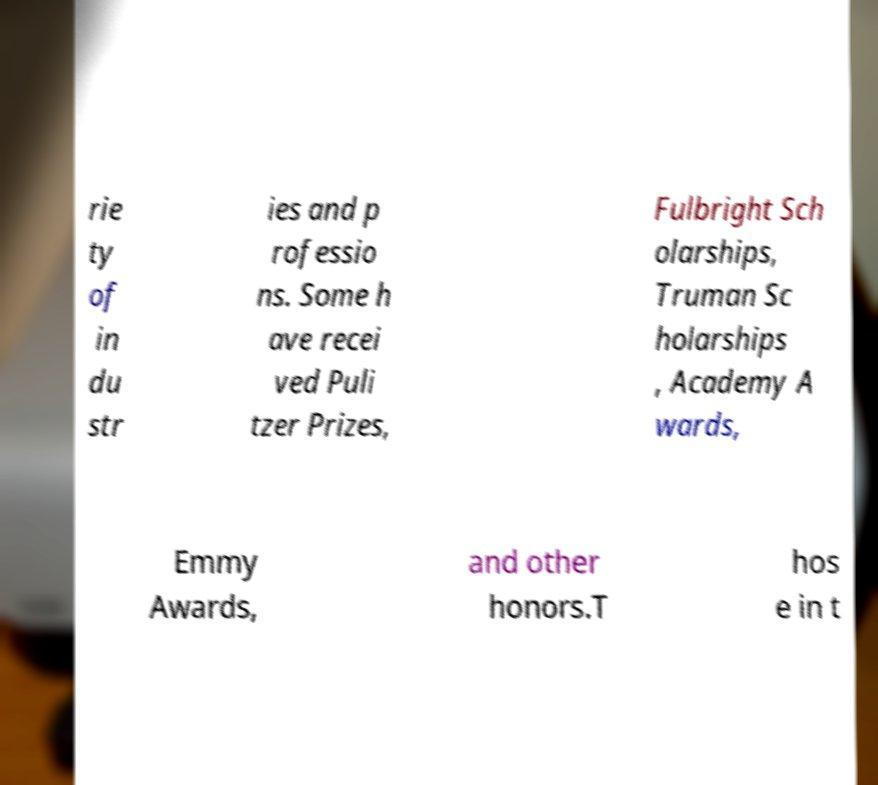Can you read and provide the text displayed in the image?This photo seems to have some interesting text. Can you extract and type it out for me? rie ty of in du str ies and p rofessio ns. Some h ave recei ved Puli tzer Prizes, Fulbright Sch olarships, Truman Sc holarships , Academy A wards, Emmy Awards, and other honors.T hos e in t 